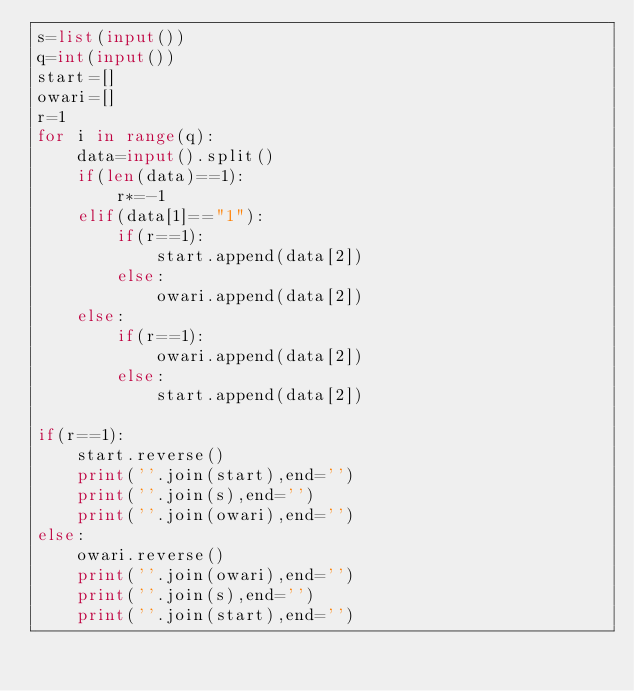<code> <loc_0><loc_0><loc_500><loc_500><_Python_>s=list(input())
q=int(input())
start=[]
owari=[]
r=1
for i in range(q):
    data=input().split()
    if(len(data)==1):
        r*=-1
    elif(data[1]=="1"):
        if(r==1):
            start.append(data[2])
        else:
            owari.append(data[2])
    else:
        if(r==1):
            owari.append(data[2])
        else:
            start.append(data[2])

if(r==1):
    start.reverse()
    print(''.join(start),end='')
    print(''.join(s),end='')
    print(''.join(owari),end='')
else:
    owari.reverse()
    print(''.join(owari),end='')
    print(''.join(s),end='')
    print(''.join(start),end='')
</code> 